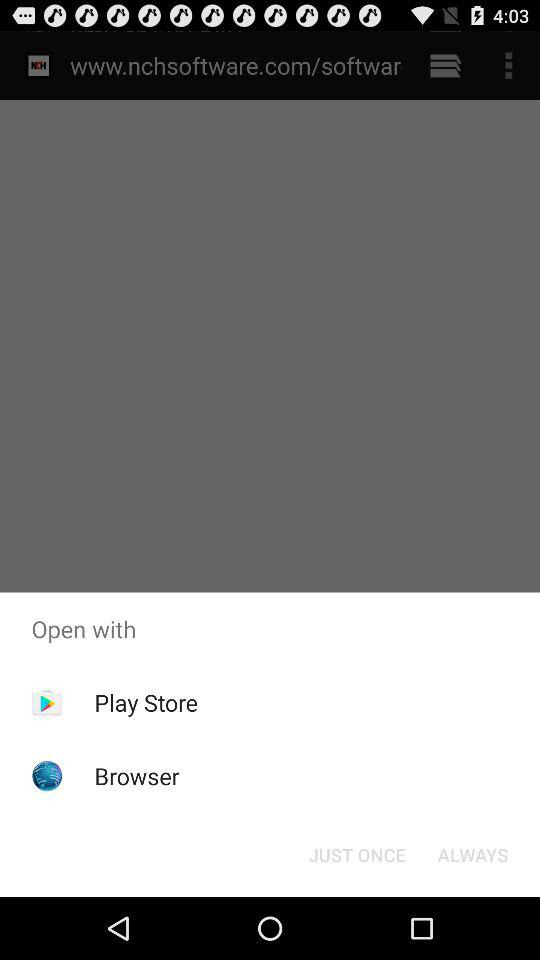What is the version number?
When the provided information is insufficient, respond with <no answer>. <no answer> 